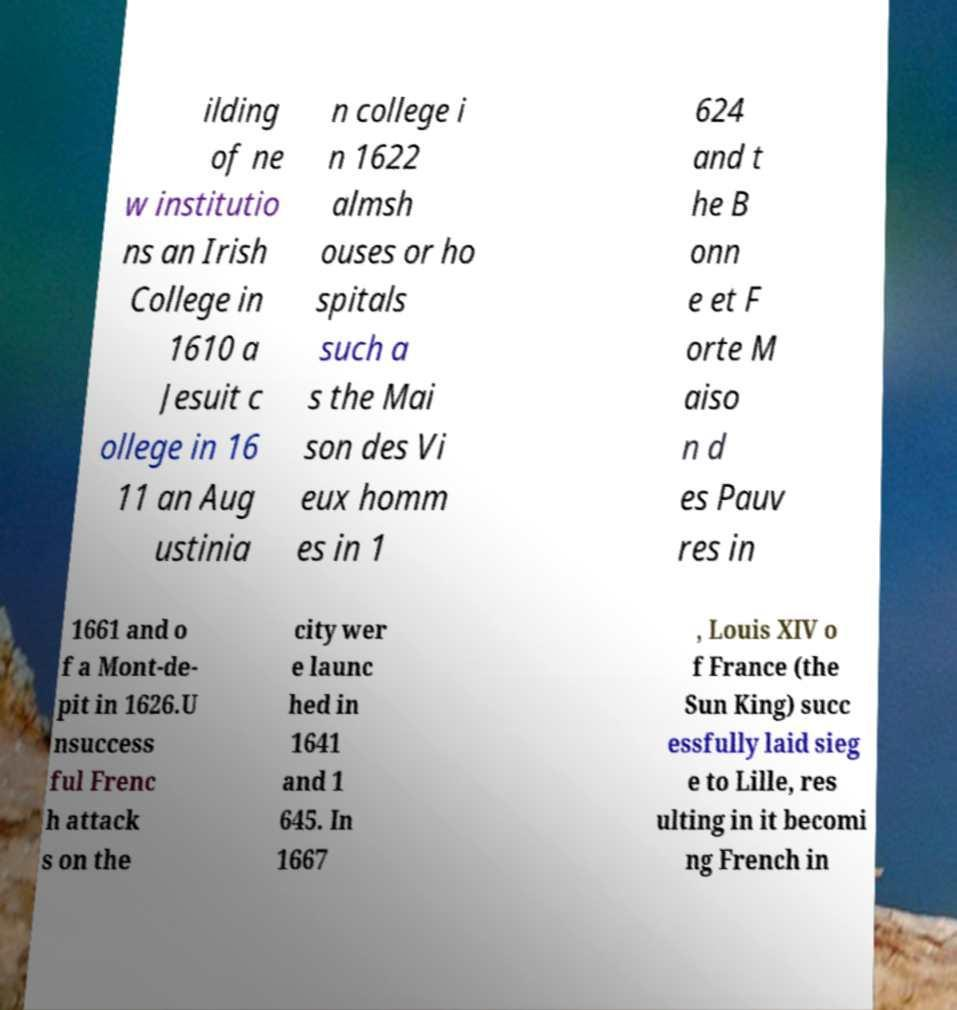Can you accurately transcribe the text from the provided image for me? ilding of ne w institutio ns an Irish College in 1610 a Jesuit c ollege in 16 11 an Aug ustinia n college i n 1622 almsh ouses or ho spitals such a s the Mai son des Vi eux homm es in 1 624 and t he B onn e et F orte M aiso n d es Pauv res in 1661 and o f a Mont-de- pit in 1626.U nsuccess ful Frenc h attack s on the city wer e launc hed in 1641 and 1 645. In 1667 , Louis XIV o f France (the Sun King) succ essfully laid sieg e to Lille, res ulting in it becomi ng French in 